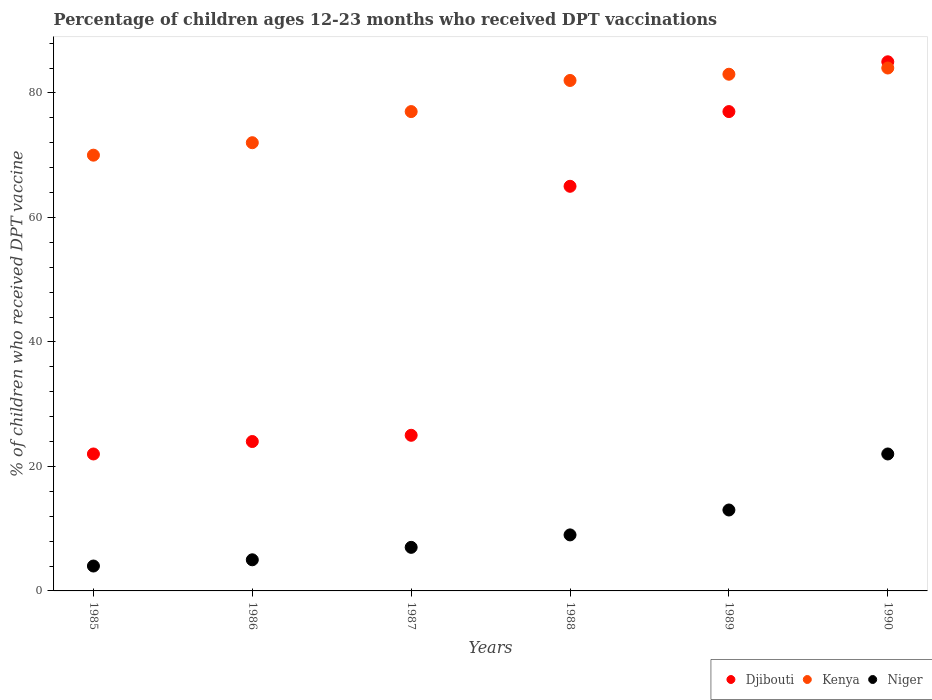Is the number of dotlines equal to the number of legend labels?
Your answer should be compact. Yes. Across all years, what is the maximum percentage of children who received DPT vaccination in Djibouti?
Your response must be concise. 85. In which year was the percentage of children who received DPT vaccination in Djibouti maximum?
Offer a terse response. 1990. In which year was the percentage of children who received DPT vaccination in Niger minimum?
Give a very brief answer. 1985. What is the difference between the percentage of children who received DPT vaccination in Djibouti in 1986 and that in 1988?
Your answer should be very brief. -41. What is the average percentage of children who received DPT vaccination in Djibouti per year?
Provide a succinct answer. 49.67. In the year 1988, what is the difference between the percentage of children who received DPT vaccination in Kenya and percentage of children who received DPT vaccination in Niger?
Provide a succinct answer. 73. What is the ratio of the percentage of children who received DPT vaccination in Kenya in 1988 to that in 1990?
Keep it short and to the point. 0.98. Is the percentage of children who received DPT vaccination in Djibouti in 1987 less than that in 1990?
Your answer should be compact. Yes. What is the difference between the highest and the second highest percentage of children who received DPT vaccination in Kenya?
Keep it short and to the point. 1. In how many years, is the percentage of children who received DPT vaccination in Niger greater than the average percentage of children who received DPT vaccination in Niger taken over all years?
Make the answer very short. 2. Is the sum of the percentage of children who received DPT vaccination in Djibouti in 1985 and 1990 greater than the maximum percentage of children who received DPT vaccination in Kenya across all years?
Ensure brevity in your answer.  Yes. Is the percentage of children who received DPT vaccination in Djibouti strictly greater than the percentage of children who received DPT vaccination in Niger over the years?
Your response must be concise. Yes. How many dotlines are there?
Provide a short and direct response. 3. How many years are there in the graph?
Keep it short and to the point. 6. What is the difference between two consecutive major ticks on the Y-axis?
Provide a short and direct response. 20. Does the graph contain grids?
Offer a very short reply. No. Where does the legend appear in the graph?
Provide a succinct answer. Bottom right. How are the legend labels stacked?
Offer a very short reply. Horizontal. What is the title of the graph?
Your answer should be very brief. Percentage of children ages 12-23 months who received DPT vaccinations. What is the label or title of the X-axis?
Provide a short and direct response. Years. What is the label or title of the Y-axis?
Ensure brevity in your answer.  % of children who received DPT vaccine. What is the % of children who received DPT vaccine in Niger in 1985?
Give a very brief answer. 4. What is the % of children who received DPT vaccine of Niger in 1986?
Provide a succinct answer. 5. What is the % of children who received DPT vaccine of Niger in 1987?
Keep it short and to the point. 7. What is the % of children who received DPT vaccine of Kenya in 1988?
Your answer should be very brief. 82. Across all years, what is the maximum % of children who received DPT vaccine in Djibouti?
Your response must be concise. 85. Across all years, what is the maximum % of children who received DPT vaccine in Kenya?
Give a very brief answer. 84. Across all years, what is the maximum % of children who received DPT vaccine in Niger?
Offer a very short reply. 22. Across all years, what is the minimum % of children who received DPT vaccine of Djibouti?
Your response must be concise. 22. Across all years, what is the minimum % of children who received DPT vaccine of Kenya?
Provide a short and direct response. 70. What is the total % of children who received DPT vaccine of Djibouti in the graph?
Your answer should be very brief. 298. What is the total % of children who received DPT vaccine in Kenya in the graph?
Your answer should be compact. 468. What is the total % of children who received DPT vaccine in Niger in the graph?
Ensure brevity in your answer.  60. What is the difference between the % of children who received DPT vaccine of Kenya in 1985 and that in 1986?
Provide a succinct answer. -2. What is the difference between the % of children who received DPT vaccine in Niger in 1985 and that in 1986?
Your answer should be compact. -1. What is the difference between the % of children who received DPT vaccine of Djibouti in 1985 and that in 1987?
Keep it short and to the point. -3. What is the difference between the % of children who received DPT vaccine in Kenya in 1985 and that in 1987?
Provide a succinct answer. -7. What is the difference between the % of children who received DPT vaccine in Djibouti in 1985 and that in 1988?
Keep it short and to the point. -43. What is the difference between the % of children who received DPT vaccine in Djibouti in 1985 and that in 1989?
Offer a terse response. -55. What is the difference between the % of children who received DPT vaccine of Djibouti in 1985 and that in 1990?
Your answer should be very brief. -63. What is the difference between the % of children who received DPT vaccine in Niger in 1985 and that in 1990?
Make the answer very short. -18. What is the difference between the % of children who received DPT vaccine of Kenya in 1986 and that in 1987?
Offer a very short reply. -5. What is the difference between the % of children who received DPT vaccine of Djibouti in 1986 and that in 1988?
Offer a very short reply. -41. What is the difference between the % of children who received DPT vaccine of Niger in 1986 and that in 1988?
Offer a terse response. -4. What is the difference between the % of children who received DPT vaccine of Djibouti in 1986 and that in 1989?
Offer a very short reply. -53. What is the difference between the % of children who received DPT vaccine in Kenya in 1986 and that in 1989?
Keep it short and to the point. -11. What is the difference between the % of children who received DPT vaccine of Niger in 1986 and that in 1989?
Make the answer very short. -8. What is the difference between the % of children who received DPT vaccine of Djibouti in 1986 and that in 1990?
Give a very brief answer. -61. What is the difference between the % of children who received DPT vaccine of Kenya in 1986 and that in 1990?
Your response must be concise. -12. What is the difference between the % of children who received DPT vaccine in Djibouti in 1987 and that in 1988?
Provide a short and direct response. -40. What is the difference between the % of children who received DPT vaccine of Kenya in 1987 and that in 1988?
Offer a terse response. -5. What is the difference between the % of children who received DPT vaccine of Niger in 1987 and that in 1988?
Make the answer very short. -2. What is the difference between the % of children who received DPT vaccine of Djibouti in 1987 and that in 1989?
Offer a terse response. -52. What is the difference between the % of children who received DPT vaccine in Niger in 1987 and that in 1989?
Provide a succinct answer. -6. What is the difference between the % of children who received DPT vaccine in Djibouti in 1987 and that in 1990?
Ensure brevity in your answer.  -60. What is the difference between the % of children who received DPT vaccine in Niger in 1987 and that in 1990?
Provide a short and direct response. -15. What is the difference between the % of children who received DPT vaccine of Djibouti in 1988 and that in 1990?
Your answer should be very brief. -20. What is the difference between the % of children who received DPT vaccine in Kenya in 1988 and that in 1990?
Ensure brevity in your answer.  -2. What is the difference between the % of children who received DPT vaccine in Niger in 1988 and that in 1990?
Ensure brevity in your answer.  -13. What is the difference between the % of children who received DPT vaccine of Djibouti in 1989 and that in 1990?
Offer a very short reply. -8. What is the difference between the % of children who received DPT vaccine in Niger in 1989 and that in 1990?
Your response must be concise. -9. What is the difference between the % of children who received DPT vaccine in Djibouti in 1985 and the % of children who received DPT vaccine in Kenya in 1987?
Make the answer very short. -55. What is the difference between the % of children who received DPT vaccine in Kenya in 1985 and the % of children who received DPT vaccine in Niger in 1987?
Keep it short and to the point. 63. What is the difference between the % of children who received DPT vaccine of Djibouti in 1985 and the % of children who received DPT vaccine of Kenya in 1988?
Your answer should be compact. -60. What is the difference between the % of children who received DPT vaccine of Kenya in 1985 and the % of children who received DPT vaccine of Niger in 1988?
Your answer should be compact. 61. What is the difference between the % of children who received DPT vaccine in Djibouti in 1985 and the % of children who received DPT vaccine in Kenya in 1989?
Offer a very short reply. -61. What is the difference between the % of children who received DPT vaccine in Kenya in 1985 and the % of children who received DPT vaccine in Niger in 1989?
Keep it short and to the point. 57. What is the difference between the % of children who received DPT vaccine of Djibouti in 1985 and the % of children who received DPT vaccine of Kenya in 1990?
Offer a terse response. -62. What is the difference between the % of children who received DPT vaccine of Djibouti in 1985 and the % of children who received DPT vaccine of Niger in 1990?
Provide a short and direct response. 0. What is the difference between the % of children who received DPT vaccine of Djibouti in 1986 and the % of children who received DPT vaccine of Kenya in 1987?
Your answer should be compact. -53. What is the difference between the % of children who received DPT vaccine in Djibouti in 1986 and the % of children who received DPT vaccine in Kenya in 1988?
Offer a very short reply. -58. What is the difference between the % of children who received DPT vaccine of Djibouti in 1986 and the % of children who received DPT vaccine of Niger in 1988?
Offer a very short reply. 15. What is the difference between the % of children who received DPT vaccine of Djibouti in 1986 and the % of children who received DPT vaccine of Kenya in 1989?
Make the answer very short. -59. What is the difference between the % of children who received DPT vaccine of Kenya in 1986 and the % of children who received DPT vaccine of Niger in 1989?
Provide a succinct answer. 59. What is the difference between the % of children who received DPT vaccine in Djibouti in 1986 and the % of children who received DPT vaccine in Kenya in 1990?
Offer a very short reply. -60. What is the difference between the % of children who received DPT vaccine of Djibouti in 1986 and the % of children who received DPT vaccine of Niger in 1990?
Make the answer very short. 2. What is the difference between the % of children who received DPT vaccine of Kenya in 1986 and the % of children who received DPT vaccine of Niger in 1990?
Your answer should be very brief. 50. What is the difference between the % of children who received DPT vaccine in Djibouti in 1987 and the % of children who received DPT vaccine in Kenya in 1988?
Offer a terse response. -57. What is the difference between the % of children who received DPT vaccine in Djibouti in 1987 and the % of children who received DPT vaccine in Niger in 1988?
Provide a succinct answer. 16. What is the difference between the % of children who received DPT vaccine of Kenya in 1987 and the % of children who received DPT vaccine of Niger in 1988?
Provide a short and direct response. 68. What is the difference between the % of children who received DPT vaccine of Djibouti in 1987 and the % of children who received DPT vaccine of Kenya in 1989?
Your response must be concise. -58. What is the difference between the % of children who received DPT vaccine in Djibouti in 1987 and the % of children who received DPT vaccine in Kenya in 1990?
Provide a short and direct response. -59. What is the difference between the % of children who received DPT vaccine of Djibouti in 1987 and the % of children who received DPT vaccine of Niger in 1990?
Provide a succinct answer. 3. What is the difference between the % of children who received DPT vaccine in Kenya in 1987 and the % of children who received DPT vaccine in Niger in 1990?
Keep it short and to the point. 55. What is the difference between the % of children who received DPT vaccine in Djibouti in 1988 and the % of children who received DPT vaccine in Niger in 1989?
Ensure brevity in your answer.  52. What is the difference between the % of children who received DPT vaccine of Djibouti in 1988 and the % of children who received DPT vaccine of Niger in 1990?
Provide a short and direct response. 43. What is the difference between the % of children who received DPT vaccine of Kenya in 1988 and the % of children who received DPT vaccine of Niger in 1990?
Give a very brief answer. 60. What is the difference between the % of children who received DPT vaccine in Djibouti in 1989 and the % of children who received DPT vaccine in Niger in 1990?
Provide a short and direct response. 55. What is the average % of children who received DPT vaccine of Djibouti per year?
Make the answer very short. 49.67. What is the average % of children who received DPT vaccine in Kenya per year?
Offer a terse response. 78. In the year 1985, what is the difference between the % of children who received DPT vaccine in Djibouti and % of children who received DPT vaccine in Kenya?
Your answer should be very brief. -48. In the year 1985, what is the difference between the % of children who received DPT vaccine in Djibouti and % of children who received DPT vaccine in Niger?
Give a very brief answer. 18. In the year 1985, what is the difference between the % of children who received DPT vaccine of Kenya and % of children who received DPT vaccine of Niger?
Offer a very short reply. 66. In the year 1986, what is the difference between the % of children who received DPT vaccine in Djibouti and % of children who received DPT vaccine in Kenya?
Provide a short and direct response. -48. In the year 1986, what is the difference between the % of children who received DPT vaccine in Djibouti and % of children who received DPT vaccine in Niger?
Provide a short and direct response. 19. In the year 1987, what is the difference between the % of children who received DPT vaccine in Djibouti and % of children who received DPT vaccine in Kenya?
Offer a very short reply. -52. In the year 1988, what is the difference between the % of children who received DPT vaccine in Djibouti and % of children who received DPT vaccine in Kenya?
Ensure brevity in your answer.  -17. In the year 1988, what is the difference between the % of children who received DPT vaccine in Kenya and % of children who received DPT vaccine in Niger?
Ensure brevity in your answer.  73. In the year 1990, what is the difference between the % of children who received DPT vaccine in Djibouti and % of children who received DPT vaccine in Kenya?
Keep it short and to the point. 1. What is the ratio of the % of children who received DPT vaccine of Djibouti in 1985 to that in 1986?
Make the answer very short. 0.92. What is the ratio of the % of children who received DPT vaccine in Kenya in 1985 to that in 1986?
Your answer should be very brief. 0.97. What is the ratio of the % of children who received DPT vaccine in Djibouti in 1985 to that in 1987?
Ensure brevity in your answer.  0.88. What is the ratio of the % of children who received DPT vaccine of Kenya in 1985 to that in 1987?
Your response must be concise. 0.91. What is the ratio of the % of children who received DPT vaccine of Djibouti in 1985 to that in 1988?
Your answer should be compact. 0.34. What is the ratio of the % of children who received DPT vaccine of Kenya in 1985 to that in 1988?
Give a very brief answer. 0.85. What is the ratio of the % of children who received DPT vaccine in Niger in 1985 to that in 1988?
Ensure brevity in your answer.  0.44. What is the ratio of the % of children who received DPT vaccine in Djibouti in 1985 to that in 1989?
Keep it short and to the point. 0.29. What is the ratio of the % of children who received DPT vaccine in Kenya in 1985 to that in 1989?
Provide a short and direct response. 0.84. What is the ratio of the % of children who received DPT vaccine of Niger in 1985 to that in 1989?
Ensure brevity in your answer.  0.31. What is the ratio of the % of children who received DPT vaccine of Djibouti in 1985 to that in 1990?
Make the answer very short. 0.26. What is the ratio of the % of children who received DPT vaccine of Kenya in 1985 to that in 1990?
Keep it short and to the point. 0.83. What is the ratio of the % of children who received DPT vaccine of Niger in 1985 to that in 1990?
Keep it short and to the point. 0.18. What is the ratio of the % of children who received DPT vaccine in Kenya in 1986 to that in 1987?
Your answer should be compact. 0.94. What is the ratio of the % of children who received DPT vaccine in Djibouti in 1986 to that in 1988?
Your answer should be very brief. 0.37. What is the ratio of the % of children who received DPT vaccine of Kenya in 1986 to that in 1988?
Make the answer very short. 0.88. What is the ratio of the % of children who received DPT vaccine of Niger in 1986 to that in 1988?
Keep it short and to the point. 0.56. What is the ratio of the % of children who received DPT vaccine of Djibouti in 1986 to that in 1989?
Your answer should be very brief. 0.31. What is the ratio of the % of children who received DPT vaccine of Kenya in 1986 to that in 1989?
Your answer should be compact. 0.87. What is the ratio of the % of children who received DPT vaccine in Niger in 1986 to that in 1989?
Your response must be concise. 0.38. What is the ratio of the % of children who received DPT vaccine of Djibouti in 1986 to that in 1990?
Give a very brief answer. 0.28. What is the ratio of the % of children who received DPT vaccine in Kenya in 1986 to that in 1990?
Offer a very short reply. 0.86. What is the ratio of the % of children who received DPT vaccine in Niger in 1986 to that in 1990?
Offer a terse response. 0.23. What is the ratio of the % of children who received DPT vaccine in Djibouti in 1987 to that in 1988?
Give a very brief answer. 0.38. What is the ratio of the % of children who received DPT vaccine of Kenya in 1987 to that in 1988?
Your answer should be compact. 0.94. What is the ratio of the % of children who received DPT vaccine of Niger in 1987 to that in 1988?
Ensure brevity in your answer.  0.78. What is the ratio of the % of children who received DPT vaccine in Djibouti in 1987 to that in 1989?
Offer a very short reply. 0.32. What is the ratio of the % of children who received DPT vaccine of Kenya in 1987 to that in 1989?
Keep it short and to the point. 0.93. What is the ratio of the % of children who received DPT vaccine of Niger in 1987 to that in 1989?
Offer a very short reply. 0.54. What is the ratio of the % of children who received DPT vaccine in Djibouti in 1987 to that in 1990?
Offer a very short reply. 0.29. What is the ratio of the % of children who received DPT vaccine of Niger in 1987 to that in 1990?
Your response must be concise. 0.32. What is the ratio of the % of children who received DPT vaccine in Djibouti in 1988 to that in 1989?
Provide a short and direct response. 0.84. What is the ratio of the % of children who received DPT vaccine of Kenya in 1988 to that in 1989?
Keep it short and to the point. 0.99. What is the ratio of the % of children who received DPT vaccine of Niger in 1988 to that in 1989?
Provide a succinct answer. 0.69. What is the ratio of the % of children who received DPT vaccine of Djibouti in 1988 to that in 1990?
Make the answer very short. 0.76. What is the ratio of the % of children who received DPT vaccine in Kenya in 1988 to that in 1990?
Provide a succinct answer. 0.98. What is the ratio of the % of children who received DPT vaccine of Niger in 1988 to that in 1990?
Keep it short and to the point. 0.41. What is the ratio of the % of children who received DPT vaccine of Djibouti in 1989 to that in 1990?
Offer a very short reply. 0.91. What is the ratio of the % of children who received DPT vaccine in Kenya in 1989 to that in 1990?
Your answer should be compact. 0.99. What is the ratio of the % of children who received DPT vaccine of Niger in 1989 to that in 1990?
Your response must be concise. 0.59. What is the difference between the highest and the second highest % of children who received DPT vaccine in Djibouti?
Make the answer very short. 8. What is the difference between the highest and the lowest % of children who received DPT vaccine of Djibouti?
Your answer should be very brief. 63. What is the difference between the highest and the lowest % of children who received DPT vaccine in Kenya?
Offer a very short reply. 14. What is the difference between the highest and the lowest % of children who received DPT vaccine of Niger?
Give a very brief answer. 18. 